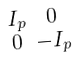Convert formula to latex. <formula><loc_0><loc_0><loc_500><loc_500>\begin{smallmatrix} I _ { p } & 0 \\ 0 & - I _ { p } \end{smallmatrix}</formula> 